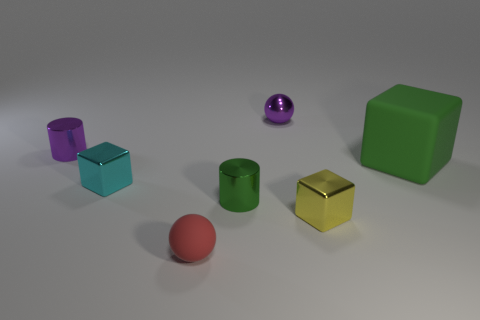Is there anything else that is the same size as the green matte cube?
Your answer should be compact. No. What is the color of the tiny metal thing that is the same shape as the small rubber object?
Offer a terse response. Purple. There is a shiny cylinder on the left side of the small matte ball; is its size the same as the object that is in front of the tiny yellow metal object?
Give a very brief answer. Yes. Are there any small yellow objects of the same shape as the large matte thing?
Ensure brevity in your answer.  Yes. Are there an equal number of purple things on the right side of the red rubber object and green matte cubes?
Your response must be concise. Yes. Does the purple shiny cylinder have the same size as the matte object that is behind the cyan thing?
Ensure brevity in your answer.  No. What number of cyan cylinders have the same material as the yellow cube?
Offer a very short reply. 0. Do the yellow thing and the red matte thing have the same size?
Offer a very short reply. Yes. Are there any other things that have the same color as the tiny metallic sphere?
Your answer should be very brief. Yes. What is the shape of the object that is behind the cyan cube and in front of the small purple shiny cylinder?
Give a very brief answer. Cube. 